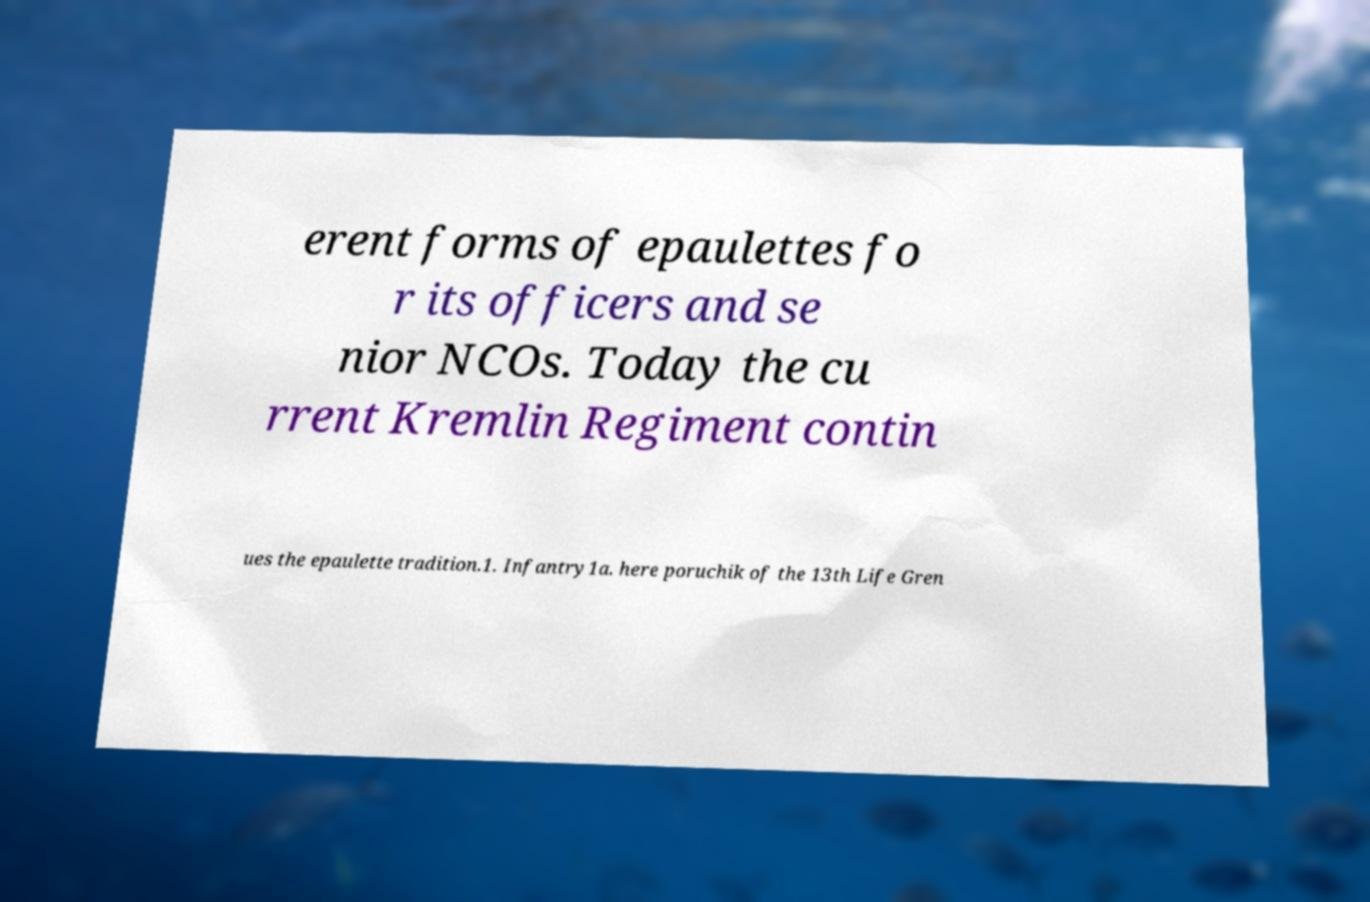Please identify and transcribe the text found in this image. erent forms of epaulettes fo r its officers and se nior NCOs. Today the cu rrent Kremlin Regiment contin ues the epaulette tradition.1. Infantry1a. here poruchik of the 13th Life Gren 